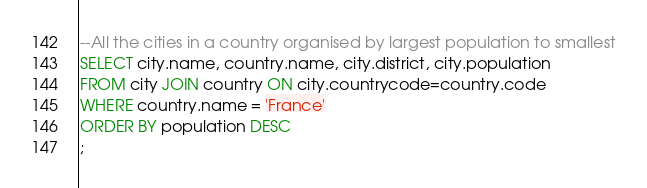Convert code to text. <code><loc_0><loc_0><loc_500><loc_500><_SQL_>--All the cities in a country organised by largest population to smallest
SELECT city.name, country.name, city.district, city.population 
FROM city JOIN country ON city.countrycode=country.code
WHERE country.name = 'France'
ORDER BY population DESC
;</code> 